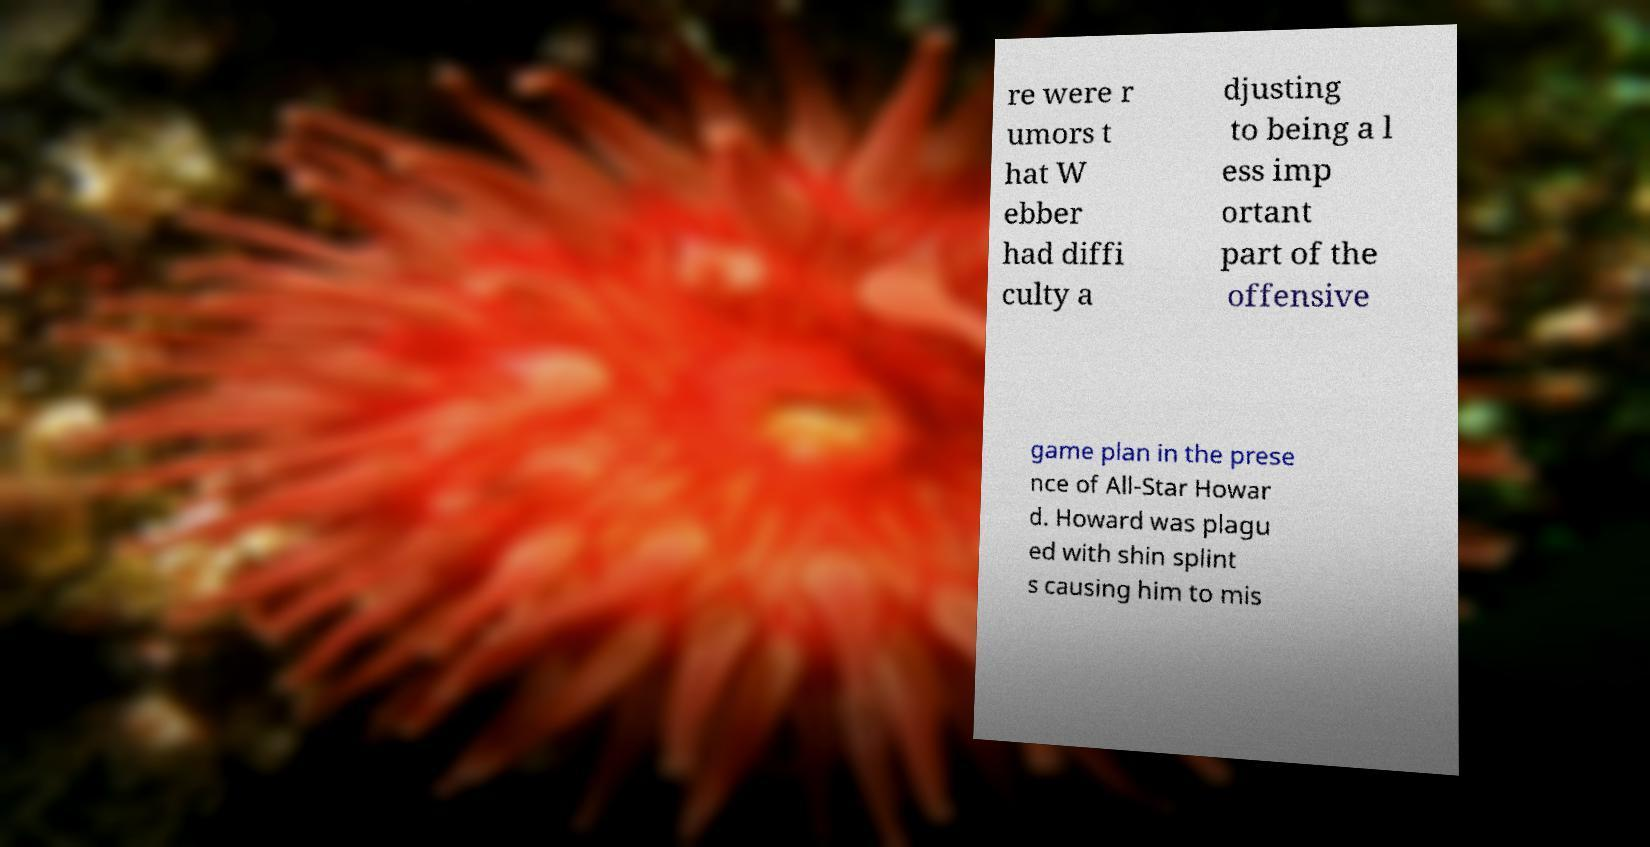Please read and relay the text visible in this image. What does it say? re were r umors t hat W ebber had diffi culty a djusting to being a l ess imp ortant part of the offensive game plan in the prese nce of All-Star Howar d. Howard was plagu ed with shin splint s causing him to mis 